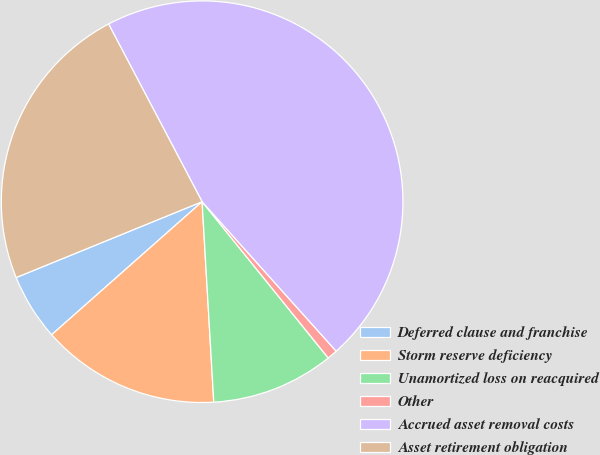<chart> <loc_0><loc_0><loc_500><loc_500><pie_chart><fcel>Deferred clause and franchise<fcel>Storm reserve deficiency<fcel>Unamortized loss on reacquired<fcel>Other<fcel>Accrued asset removal costs<fcel>Asset retirement obligation<nl><fcel>5.36%<fcel>14.4%<fcel>9.88%<fcel>0.83%<fcel>46.07%<fcel>23.45%<nl></chart> 